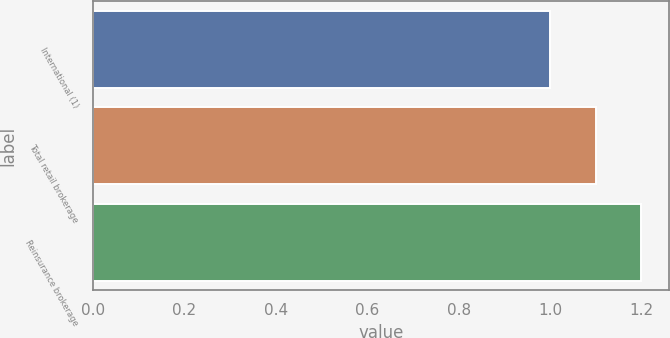Convert chart to OTSL. <chart><loc_0><loc_0><loc_500><loc_500><bar_chart><fcel>International (1)<fcel>Total retail brokerage<fcel>Reinsurance brokerage<nl><fcel>1<fcel>1.1<fcel>1.2<nl></chart> 